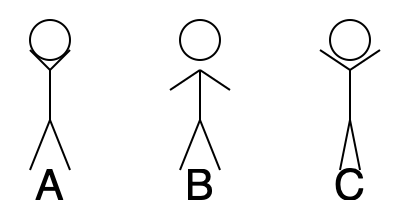As an art therapist, which stick figure pose would you interpret as expressing the most open and receptive body language, potentially indicating a client's readiness to engage in therapy? To interpret body language from these simple stick figure poses, we need to analyze the positioning of the arms and legs:

1. Figure A:
   - Arms are slightly raised and angled downward
   - Legs are spread apart
   - This pose suggests a neutral or slightly defensive stance

2. Figure B:
   - Arms are raised and angled upward
   - Legs are spread apart
   - This pose indicates openness and receptivity

3. Figure C:
   - Arms are raised high and angled outward
   - Legs are close together
   - This pose suggests excitement or alarm, but may also indicate tension

In the context of art therapy and mental health:

- Open postures, like Figure B, generally indicate receptivity and willingness to engage
- Raised arms, as in Figure B, can signify openness to new ideas or experiences
- A balanced stance with legs slightly apart, as in Figure B, suggests stability and groundedness

Therefore, Figure B represents the most open and receptive body language, potentially indicating a client's readiness to engage in therapy.
Answer: Figure B 